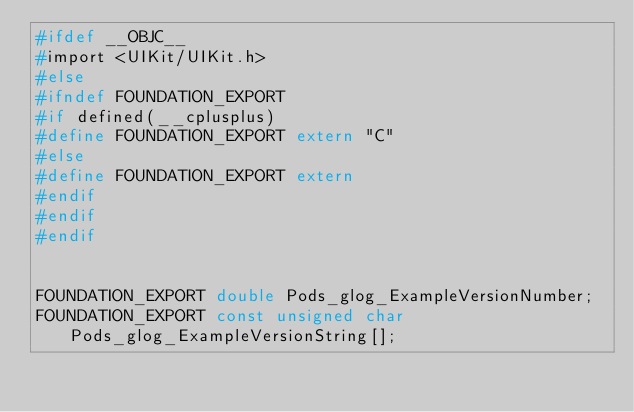Convert code to text. <code><loc_0><loc_0><loc_500><loc_500><_C_>#ifdef __OBJC__
#import <UIKit/UIKit.h>
#else
#ifndef FOUNDATION_EXPORT
#if defined(__cplusplus)
#define FOUNDATION_EXPORT extern "C"
#else
#define FOUNDATION_EXPORT extern
#endif
#endif
#endif


FOUNDATION_EXPORT double Pods_glog_ExampleVersionNumber;
FOUNDATION_EXPORT const unsigned char Pods_glog_ExampleVersionString[];

</code> 